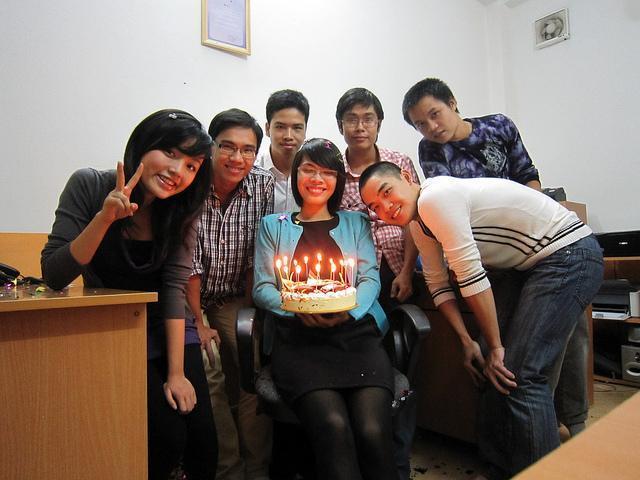How many ladies are wearing white tops?
Give a very brief answer. 0. How many people are in the picture?
Give a very brief answer. 7. How many people are there?
Give a very brief answer. 7. How many people are looking at the camera?
Give a very brief answer. 7. How many people can you see?
Give a very brief answer. 7. How many elephants do you think there are?
Give a very brief answer. 0. 